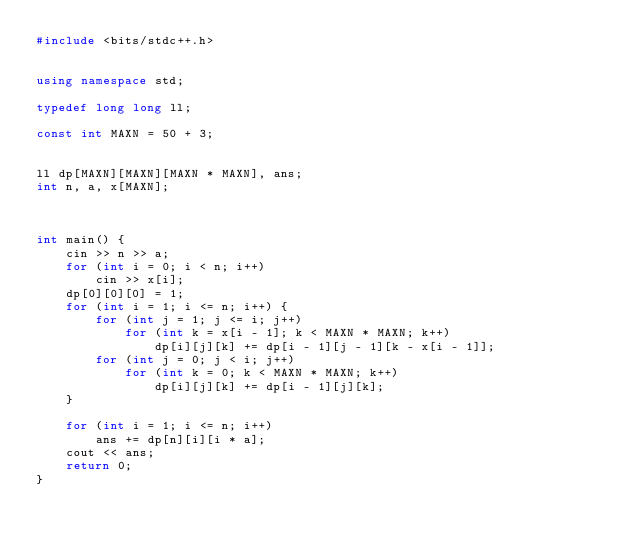Convert code to text. <code><loc_0><loc_0><loc_500><loc_500><_C++_>#include <bits/stdc++.h>


using namespace std;

typedef long long ll;

const int MAXN = 50 + 3;


ll dp[MAXN][MAXN][MAXN * MAXN], ans;
int n, a, x[MAXN];



int main() {
	cin >> n >> a;
	for (int i = 0; i < n; i++)
		cin >> x[i];
	dp[0][0][0] = 1;
	for (int i = 1; i <= n; i++) {
		for (int j = 1; j <= i; j++)
			for (int k = x[i - 1]; k < MAXN * MAXN; k++)
				dp[i][j][k] += dp[i - 1][j - 1][k - x[i - 1]];
		for (int j = 0; j < i; j++)
			for (int k = 0; k < MAXN * MAXN; k++)
				dp[i][j][k] += dp[i - 1][j][k];
	}
	
	for (int i = 1; i <= n; i++)
		ans += dp[n][i][i * a];
	cout << ans;
	return 0;
}</code> 